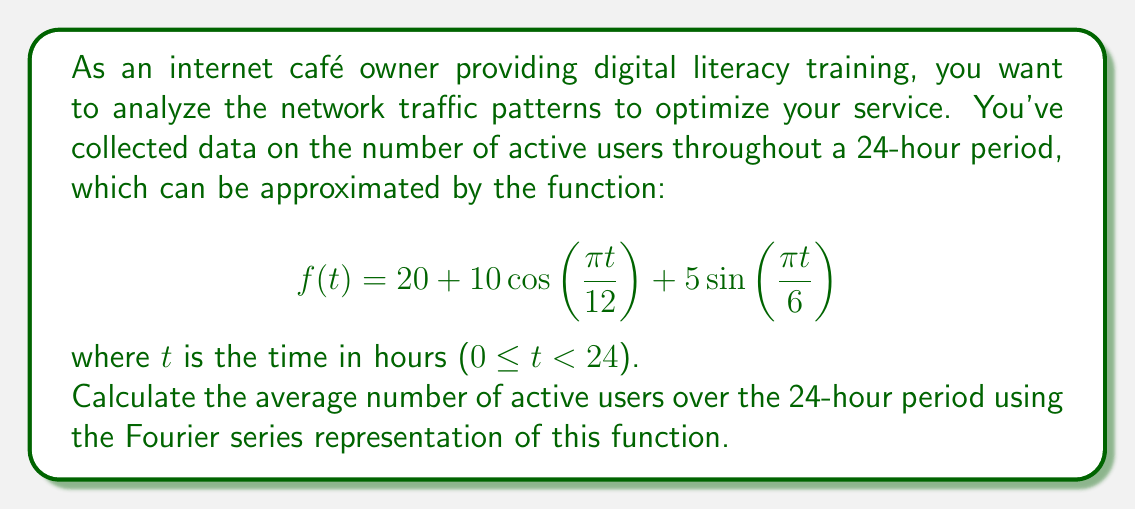Help me with this question. To solve this problem, we'll follow these steps:

1) First, recall that the average value of a periodic function over its period is equal to the constant term (a₀) in its Fourier series representation.

2) The given function is already in the form of a Fourier series:
   $$f(t) = a_0 + a_1\cos(\frac{\pi t}{12}) + b_1\sin(\frac{\pi t}{6})$$

3) Comparing this with the standard form of a Fourier series:
   $$f(t) = \frac{a_0}{2} + \sum_{n=1}^{\infty} [a_n\cos(\frac{2\pi nt}{T}) + b_n\sin(\frac{2\pi nt}{T})]$$

4) We can identify:
   - $a_0 = 40$ (because $\frac{a_0}{2} = 20$)
   - $a_1 = 10$
   - $b_1 = 5$
   - The period $T = 24$ hours

5) The average number of active users is given by $\frac{a_0}{2}$, which is 20.

This means that over a 24-hour period, the average number of active users in your internet café is 20.
Answer: The average number of active users over the 24-hour period is 20. 